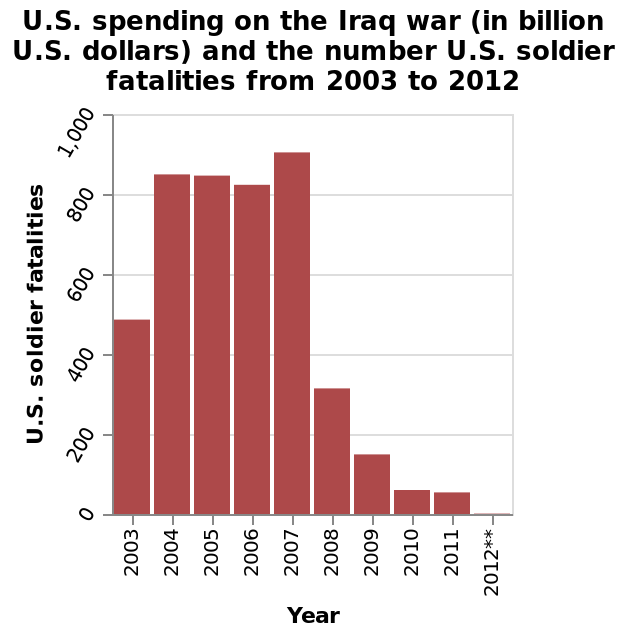<image>
please summary the statistics and relations of the chart The number of fat it is He thinks I’m grateful as we are off on. Why does he think about the number of fat?  He thinks I'm grateful as we are off on. 